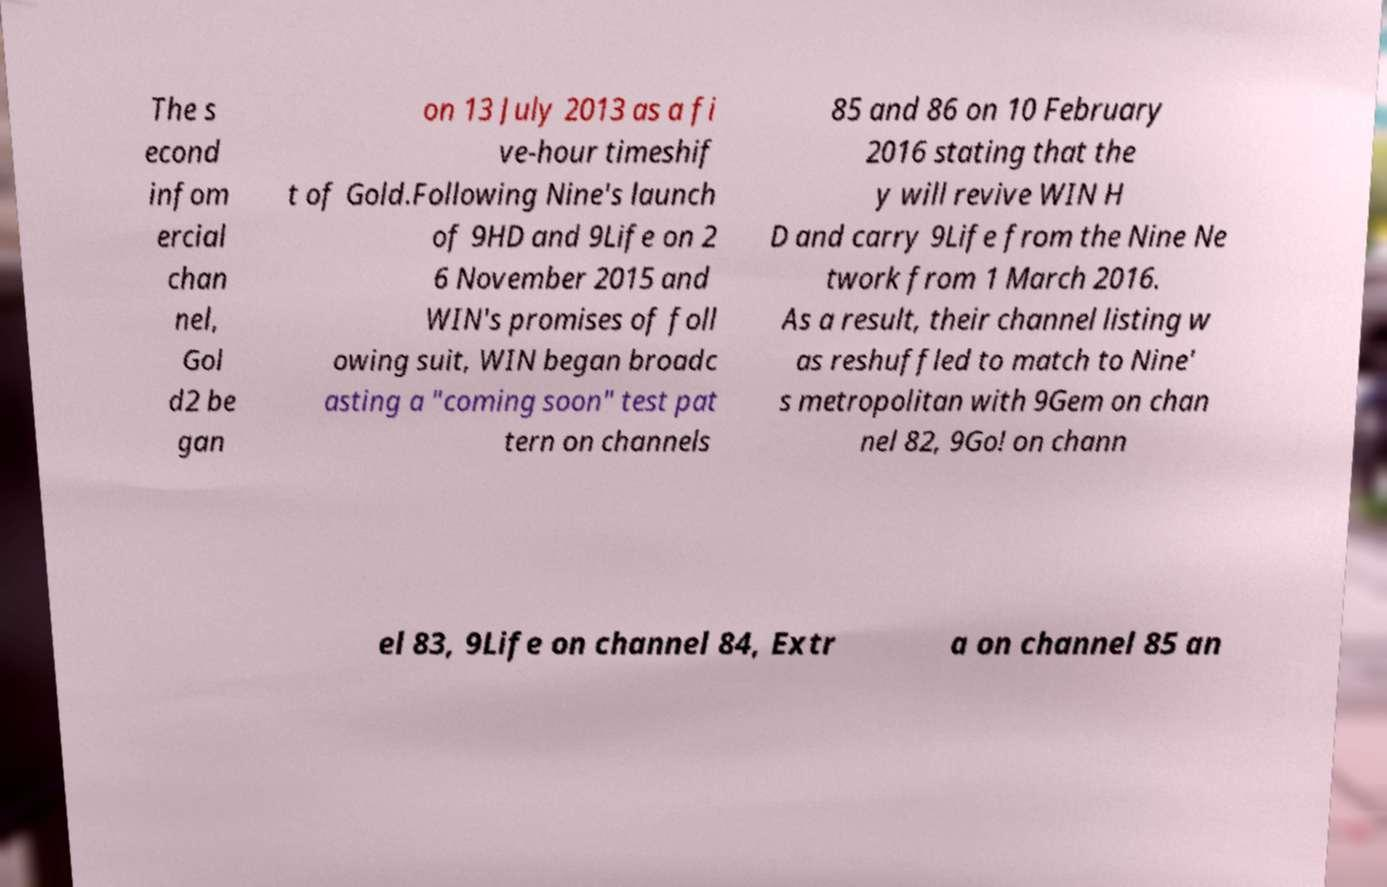Could you assist in decoding the text presented in this image and type it out clearly? The s econd infom ercial chan nel, Gol d2 be gan on 13 July 2013 as a fi ve-hour timeshif t of Gold.Following Nine's launch of 9HD and 9Life on 2 6 November 2015 and WIN's promises of foll owing suit, WIN began broadc asting a "coming soon" test pat tern on channels 85 and 86 on 10 February 2016 stating that the y will revive WIN H D and carry 9Life from the Nine Ne twork from 1 March 2016. As a result, their channel listing w as reshuffled to match to Nine' s metropolitan with 9Gem on chan nel 82, 9Go! on chann el 83, 9Life on channel 84, Extr a on channel 85 an 